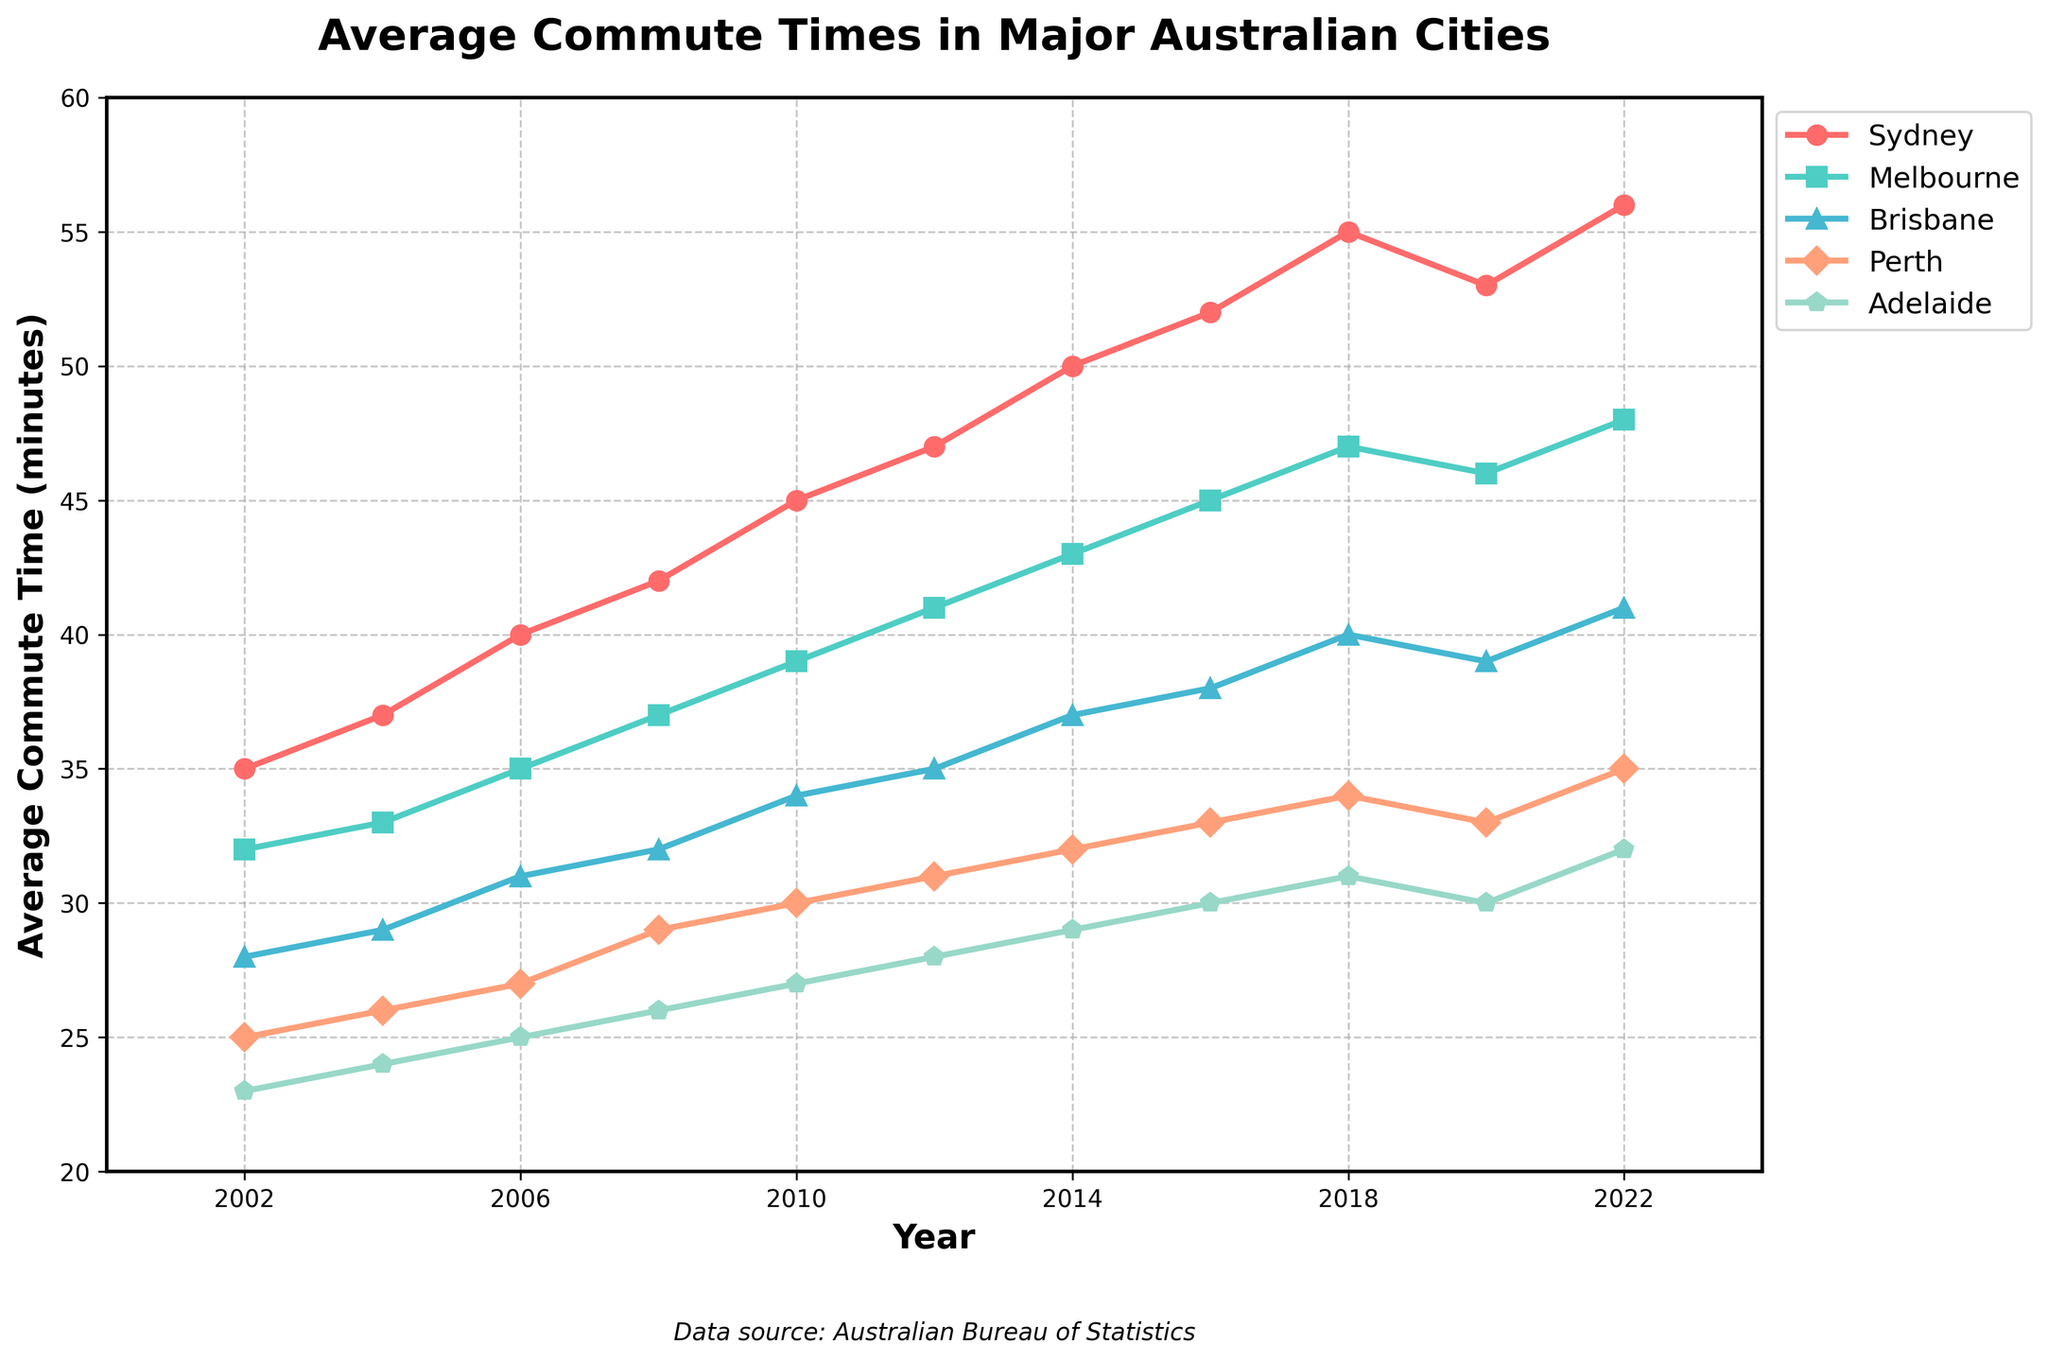What's the trend in average commute time for Sydney over the past 20 years? Look at the line representing Sydney. Trace the line from 2002 to 2022 to see if it generally rises, falls, or stays constant. The line shows a general rise in values.
Answer: Increasing What was the average commute time difference between Melbourne and Brisbane in 2022? Find the values for Melbourne and Brisbane in 2022 from the chart. Subtract Brisbane's value from Melbourne's value (48 - 41).
Answer: 7 minutes Which city had the lowest average commute time in 2002? Look at the 2002 data points for all cities and identify the lowest value. Adelaide, with 23 minutes, is the lowest.
Answer: Adelaide In 2018, was Perth's average commute time higher or lower than Brisbane's? Compare the heights of the points for Perth and Brisbane in 2018. Perth's value (34) is lower than Brisbane's (40).
Answer: Lower Between which consecutive years did Sydney see the most significant increase in average commute times? Calculate the difference in Sydney's commute times between consecutive years. The highest difference is between 2018 and 2020 (55 - 53).
Answer: 2018 to 2020 Calculate the average commute time for all cities combined in 2020. Sum the values for all cities in 2020 (53 + 46 + 39 + 33 + 30) and divide by the number of cities, which is 5. The sum is 201, and the average is 201/5.
Answer: 40.2 minutes How much did Adelaide's average commute time increase from 2010 to 2022? Find Adelaide's values for 2010 and 2022. Subtract the 2010 value from the 2022 value (32 - 27).
Answer: 5 minutes Which two cities had the closest average commute times in 2008? Compare the values for all cities in 2008 and find the two closest values. Brisbane (32) and Melbourne (37) have a difference of 5 minutes, the closest.
Answer: Brisbane and Melbourne What color represents Perth's average commute time on the chart? Identify Perth's line on the figure and describe its color. The color representing Perth is indicated by one of the plotted lines.
Answer: Red (or whatever matches the color used in the figure) 